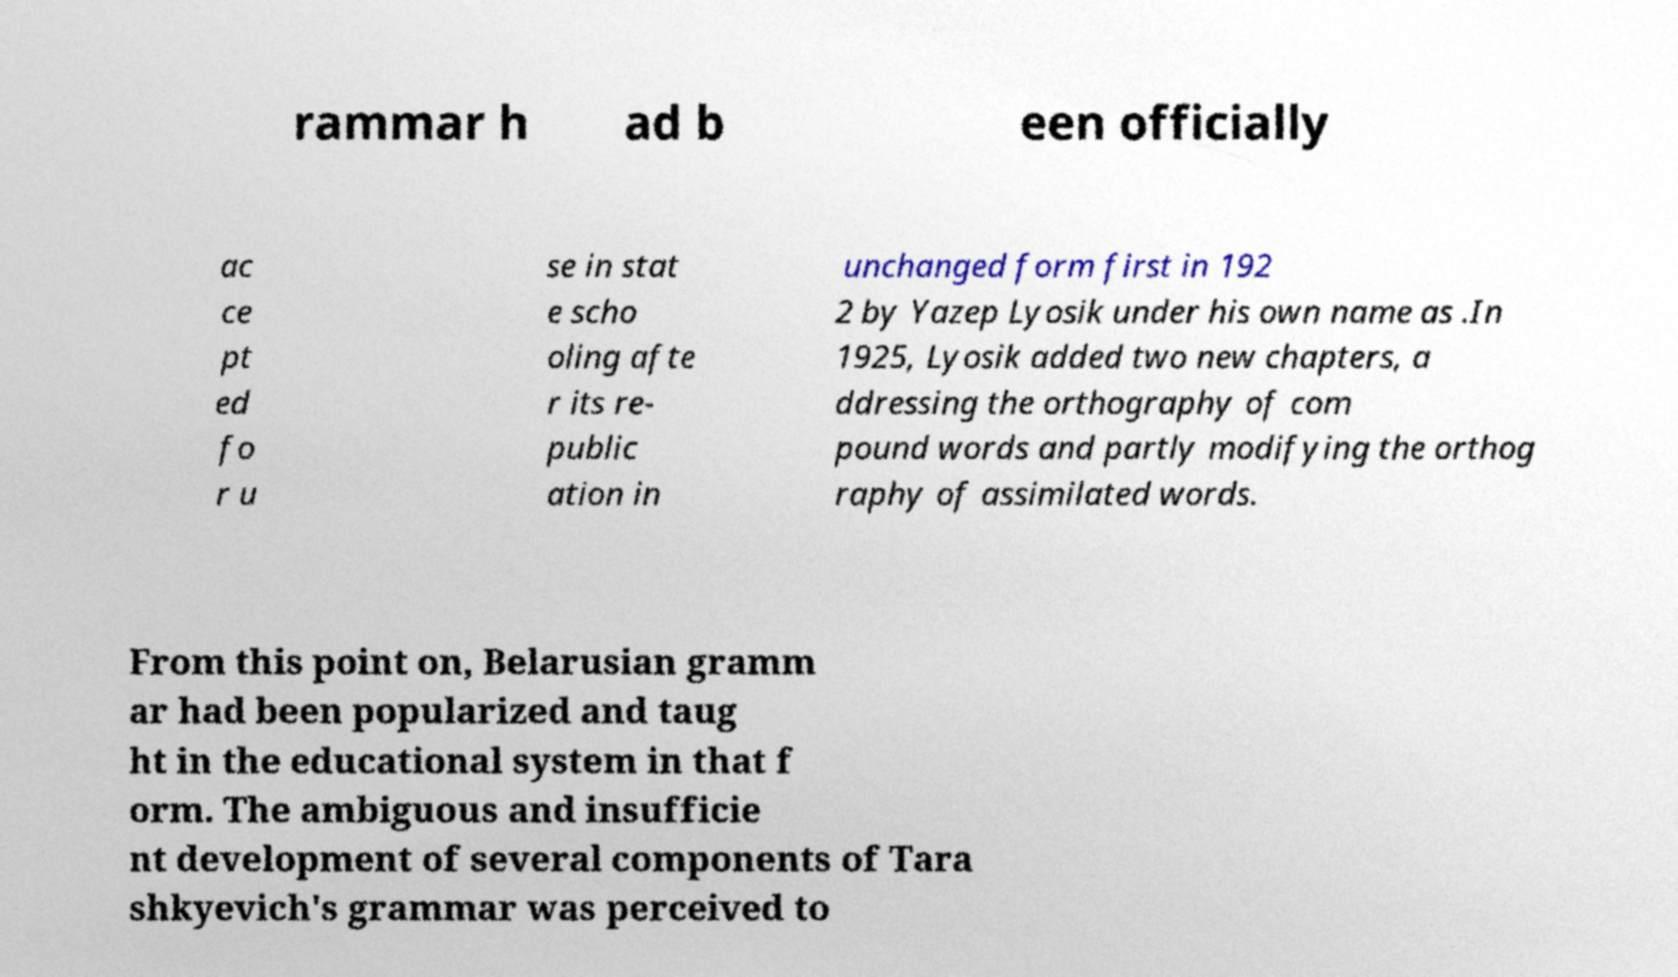Please identify and transcribe the text found in this image. rammar h ad b een officially ac ce pt ed fo r u se in stat e scho oling afte r its re- public ation in unchanged form first in 192 2 by Yazep Lyosik under his own name as .In 1925, Lyosik added two new chapters, a ddressing the orthography of com pound words and partly modifying the orthog raphy of assimilated words. From this point on, Belarusian gramm ar had been popularized and taug ht in the educational system in that f orm. The ambiguous and insufficie nt development of several components of Tara shkyevich's grammar was perceived to 